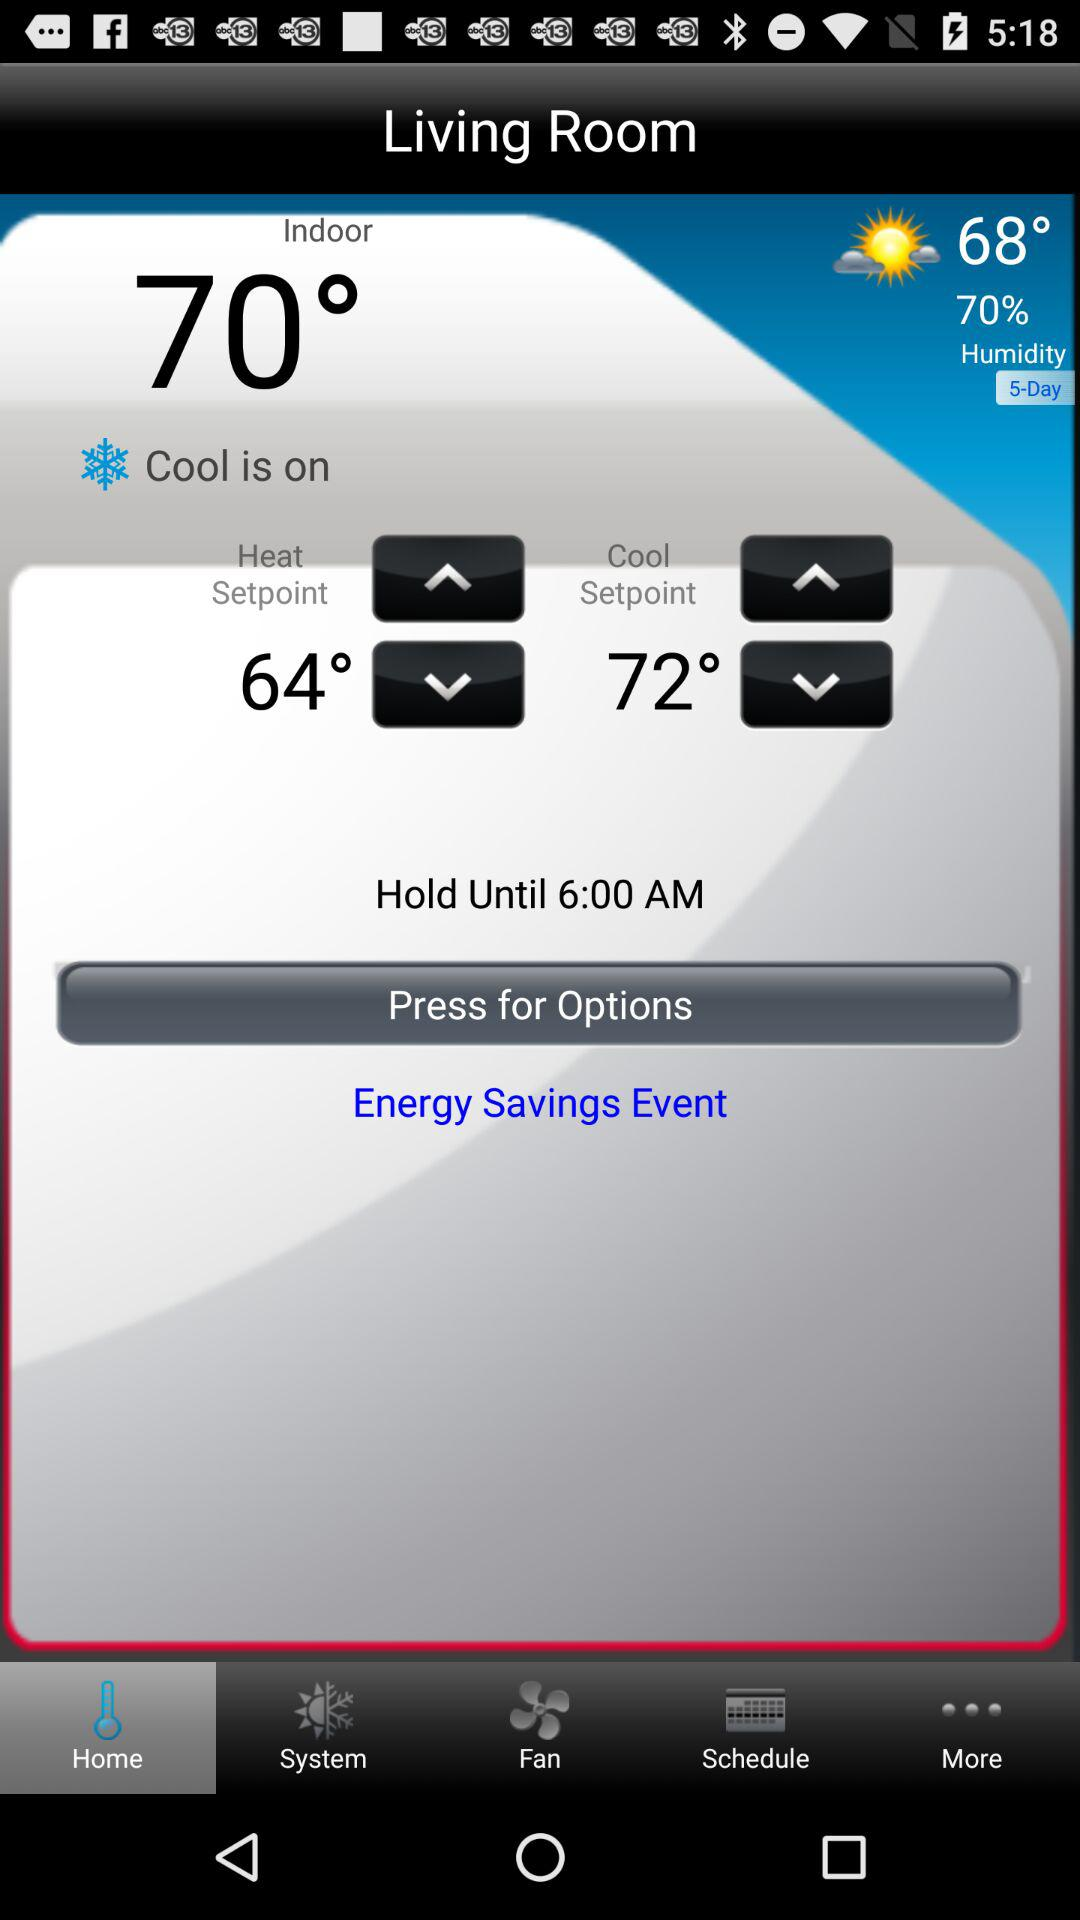What is the humidity percentage? The humidity percentage is 70. 